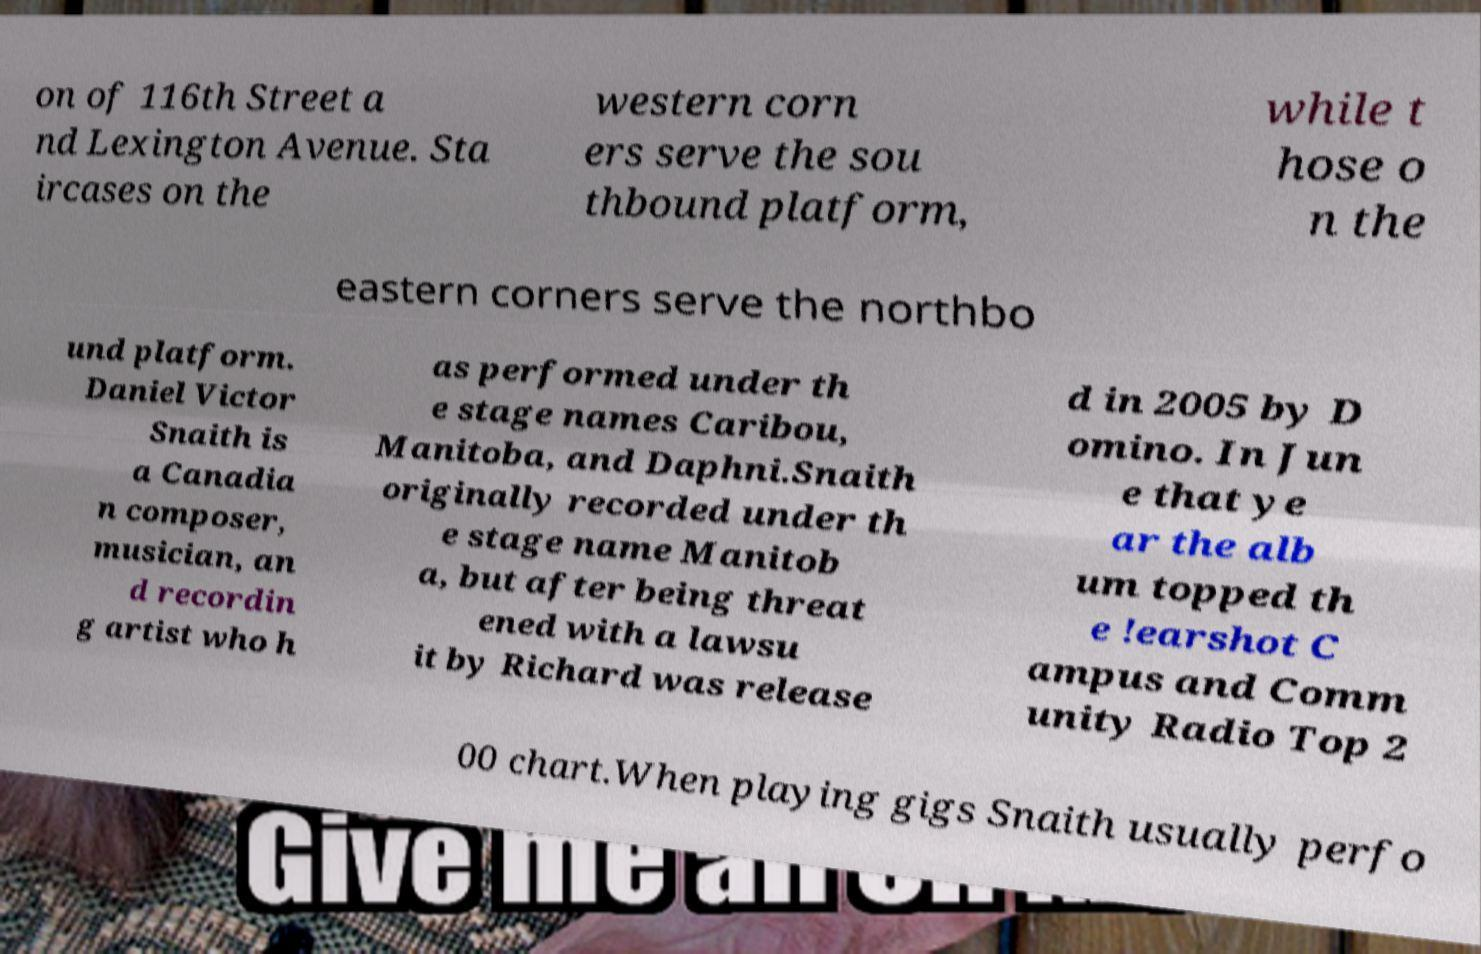Could you extract and type out the text from this image? on of 116th Street a nd Lexington Avenue. Sta ircases on the western corn ers serve the sou thbound platform, while t hose o n the eastern corners serve the northbo und platform. Daniel Victor Snaith is a Canadia n composer, musician, an d recordin g artist who h as performed under th e stage names Caribou, Manitoba, and Daphni.Snaith originally recorded under th e stage name Manitob a, but after being threat ened with a lawsu it by Richard was release d in 2005 by D omino. In Jun e that ye ar the alb um topped th e !earshot C ampus and Comm unity Radio Top 2 00 chart.When playing gigs Snaith usually perfo 